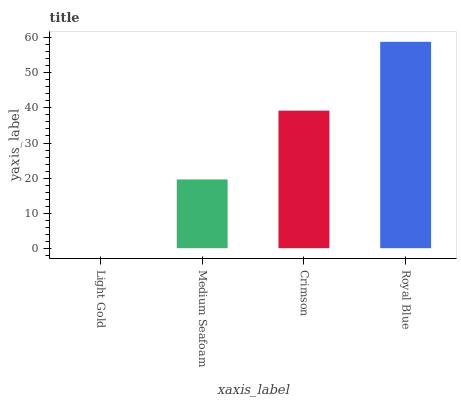Is Medium Seafoam the minimum?
Answer yes or no. No. Is Medium Seafoam the maximum?
Answer yes or no. No. Is Medium Seafoam greater than Light Gold?
Answer yes or no. Yes. Is Light Gold less than Medium Seafoam?
Answer yes or no. Yes. Is Light Gold greater than Medium Seafoam?
Answer yes or no. No. Is Medium Seafoam less than Light Gold?
Answer yes or no. No. Is Crimson the high median?
Answer yes or no. Yes. Is Medium Seafoam the low median?
Answer yes or no. Yes. Is Royal Blue the high median?
Answer yes or no. No. Is Light Gold the low median?
Answer yes or no. No. 